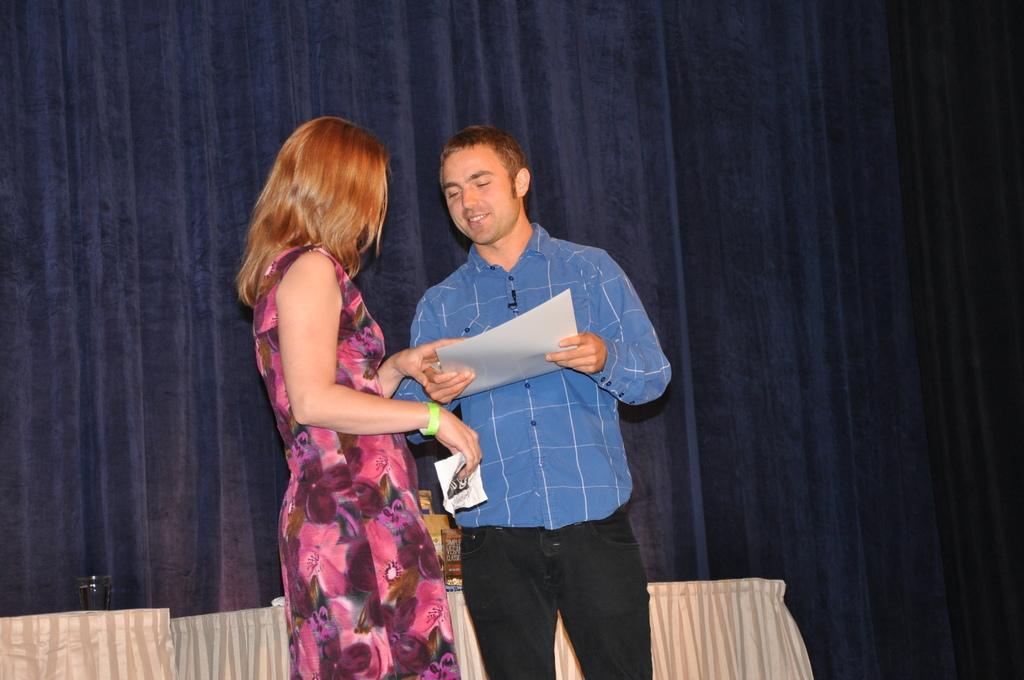How would you summarize this image in a sentence or two? In this picture, we see the woman in pink dress and the man in blue shirt are standing. The man is holding a paper in his hand and he is smiling. We even see the woman is holding a paper in her hand. Behind them, we see the tables which are covered with white color sheets. We see a glass is placed on the table. In the background, we see a sheet and a curtain in blue color. 